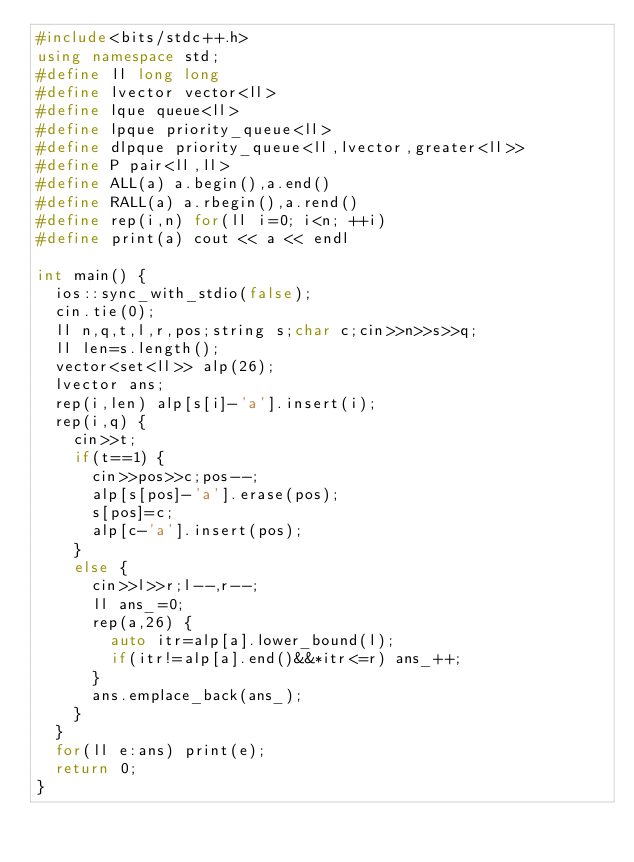Convert code to text. <code><loc_0><loc_0><loc_500><loc_500><_C++_>#include<bits/stdc++.h>
using namespace std;
#define ll long long
#define lvector vector<ll>
#define lque queue<ll>
#define lpque priority_queue<ll>
#define dlpque priority_queue<ll,lvector,greater<ll>>
#define P pair<ll,ll>
#define ALL(a) a.begin(),a.end()
#define RALL(a) a.rbegin(),a.rend()
#define rep(i,n) for(ll i=0; i<n; ++i)
#define print(a) cout << a << endl

int main() {
  ios::sync_with_stdio(false);
  cin.tie(0);
  ll n,q,t,l,r,pos;string s;char c;cin>>n>>s>>q;
  ll len=s.length();
  vector<set<ll>> alp(26);
  lvector ans;
  rep(i,len) alp[s[i]-'a'].insert(i);
  rep(i,q) {
    cin>>t;
    if(t==1) {
      cin>>pos>>c;pos--;
      alp[s[pos]-'a'].erase(pos);
      s[pos]=c;
      alp[c-'a'].insert(pos);
    }
    else {
      cin>>l>>r;l--,r--;
      ll ans_=0;
      rep(a,26) {
        auto itr=alp[a].lower_bound(l);
        if(itr!=alp[a].end()&&*itr<=r) ans_++;
      }
      ans.emplace_back(ans_);
    }
  }
  for(ll e:ans) print(e);
  return 0;
}</code> 